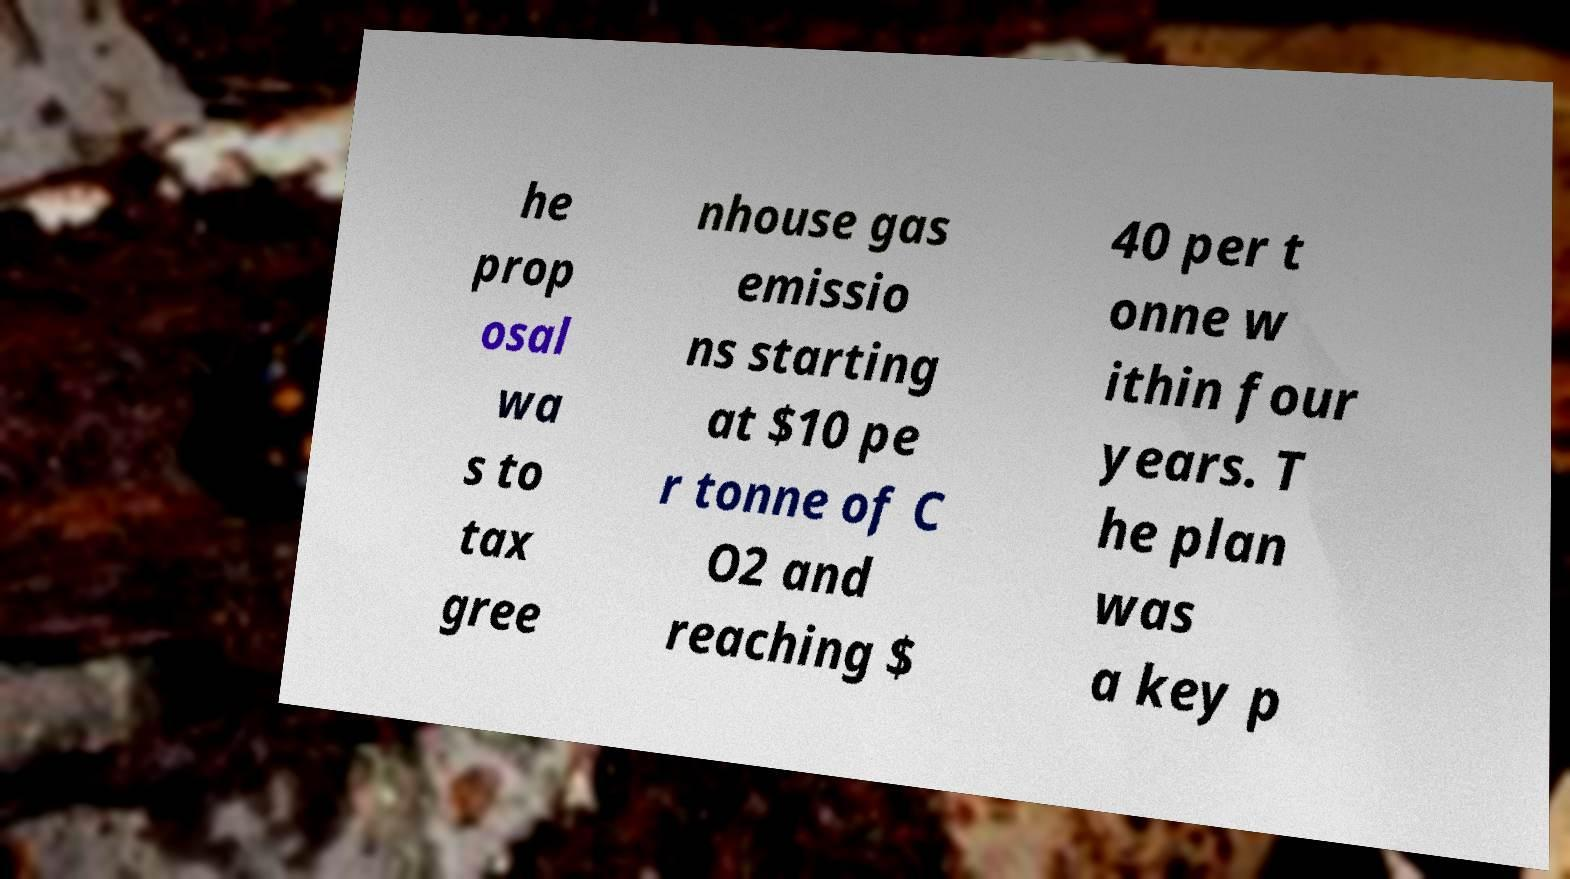Can you read and provide the text displayed in the image?This photo seems to have some interesting text. Can you extract and type it out for me? he prop osal wa s to tax gree nhouse gas emissio ns starting at $10 pe r tonne of C O2 and reaching $ 40 per t onne w ithin four years. T he plan was a key p 